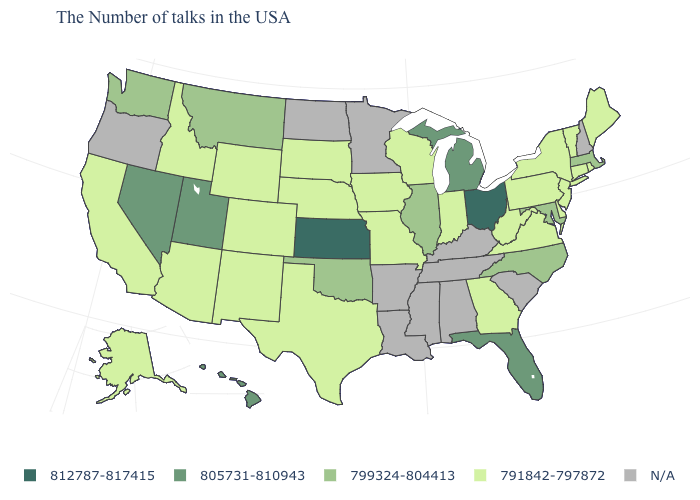Name the states that have a value in the range 812787-817415?
Short answer required. Ohio, Kansas. What is the value of Iowa?
Keep it brief. 791842-797872. What is the value of Idaho?
Be succinct. 791842-797872. What is the value of South Carolina?
Give a very brief answer. N/A. Does the map have missing data?
Keep it brief. Yes. Name the states that have a value in the range 791842-797872?
Short answer required. Maine, Rhode Island, Vermont, Connecticut, New York, New Jersey, Delaware, Pennsylvania, Virginia, West Virginia, Georgia, Indiana, Wisconsin, Missouri, Iowa, Nebraska, Texas, South Dakota, Wyoming, Colorado, New Mexico, Arizona, Idaho, California, Alaska. What is the value of Washington?
Be succinct. 799324-804413. Which states have the highest value in the USA?
Short answer required. Ohio, Kansas. Name the states that have a value in the range 805731-810943?
Short answer required. Florida, Michigan, Utah, Nevada, Hawaii. Does Nebraska have the highest value in the MidWest?
Short answer required. No. Name the states that have a value in the range 791842-797872?
Short answer required. Maine, Rhode Island, Vermont, Connecticut, New York, New Jersey, Delaware, Pennsylvania, Virginia, West Virginia, Georgia, Indiana, Wisconsin, Missouri, Iowa, Nebraska, Texas, South Dakota, Wyoming, Colorado, New Mexico, Arizona, Idaho, California, Alaska. Name the states that have a value in the range 791842-797872?
Give a very brief answer. Maine, Rhode Island, Vermont, Connecticut, New York, New Jersey, Delaware, Pennsylvania, Virginia, West Virginia, Georgia, Indiana, Wisconsin, Missouri, Iowa, Nebraska, Texas, South Dakota, Wyoming, Colorado, New Mexico, Arizona, Idaho, California, Alaska. What is the highest value in states that border Florida?
Answer briefly. 791842-797872. Name the states that have a value in the range 799324-804413?
Short answer required. Massachusetts, Maryland, North Carolina, Illinois, Oklahoma, Montana, Washington. 